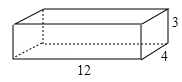First perform reasoning, then finally select the question from the choices in the following format: Answer: xxx.
Question: Let's consider a wooden box with dimensions of length, width, and height as variables 'l', 'w', and 'h' respectively (l = 12.0, w = 4.0, h = 3.0). What is the maximum length of a thin wooden strip that can be placed inside the box without protruding? Express the maximum length as 'x' in terms of 'l', 'w', and 'h'.
Choices:
A: 13cm
B: 14cm
C: 15cm
D: 16cm To determine the maximum length of the thin wooden strip, we need to find the longest line segment in the wooden box, which is represented by AD. Applying the Pythagorean theorem to right triangle ABC, we have AC² = AB² + BC² = l² + w² = 12.0² + 4.0² = 160. Similarly, in right triangle ACD, using the Pythagorean theorem, we have AD² = AC² + CD² = 160 + h² = 160 + 3.0² = 169. Taking the square root of both sides, we get AD = √169 = 13. Therefore, the maximum length of the thin wooden strip that can be placed inside the box without protruding is 13. Thus, the answer is option A.
Answer:A 